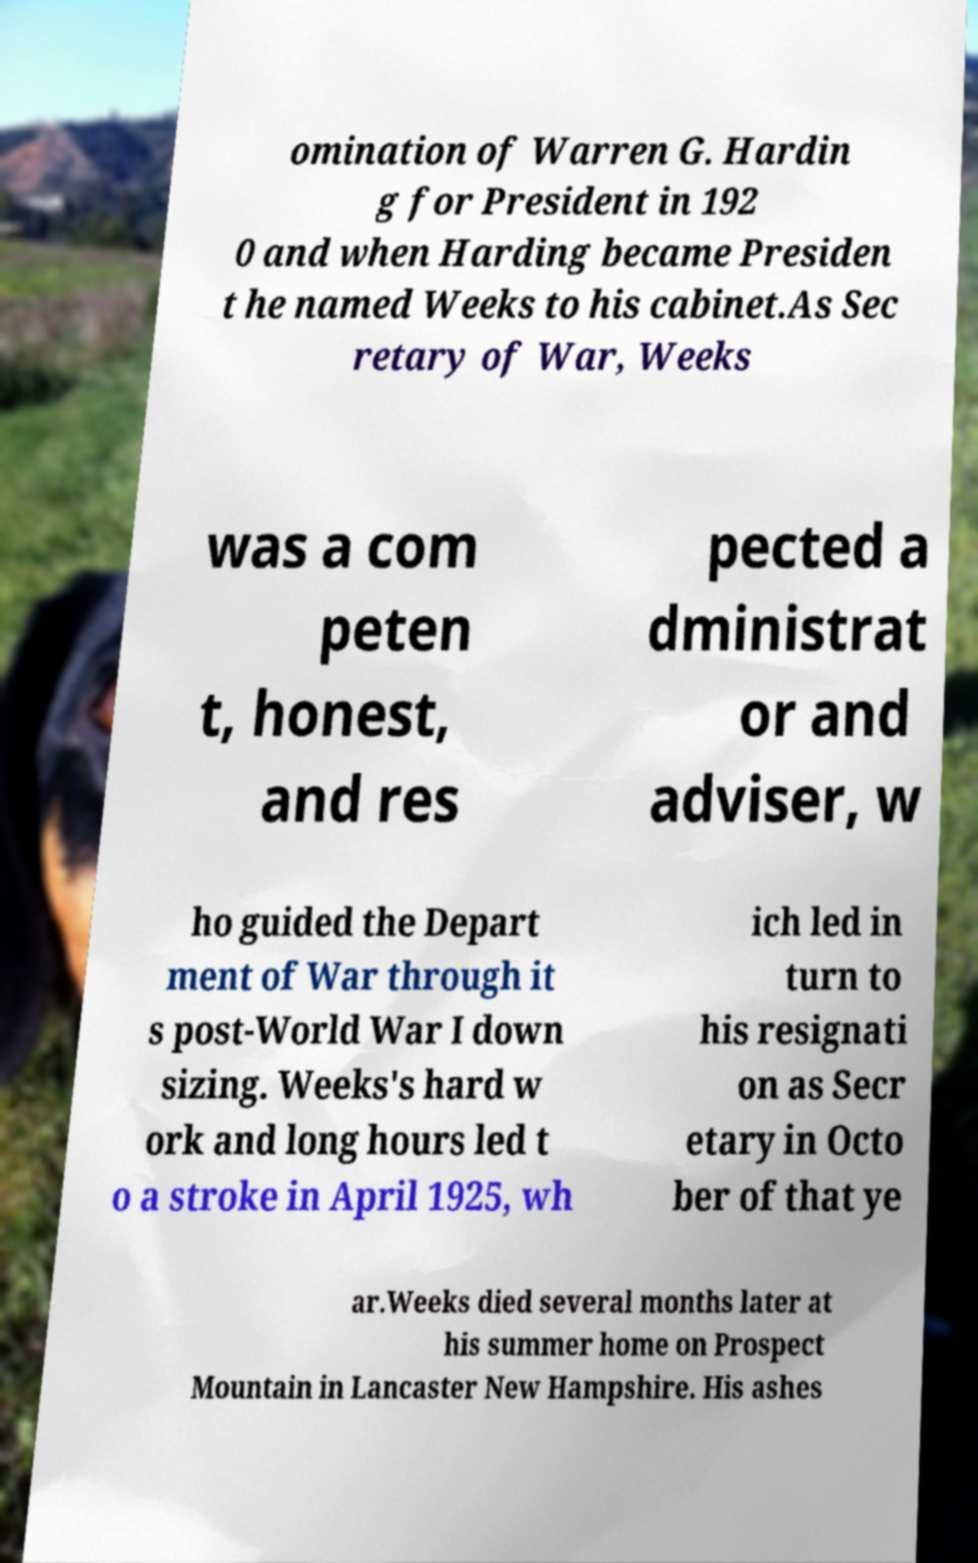There's text embedded in this image that I need extracted. Can you transcribe it verbatim? omination of Warren G. Hardin g for President in 192 0 and when Harding became Presiden t he named Weeks to his cabinet.As Sec retary of War, Weeks was a com peten t, honest, and res pected a dministrat or and adviser, w ho guided the Depart ment of War through it s post-World War I down sizing. Weeks's hard w ork and long hours led t o a stroke in April 1925, wh ich led in turn to his resignati on as Secr etary in Octo ber of that ye ar.Weeks died several months later at his summer home on Prospect Mountain in Lancaster New Hampshire. His ashes 